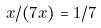<formula> <loc_0><loc_0><loc_500><loc_500>x / ( 7 x ) = 1 / 7</formula> 